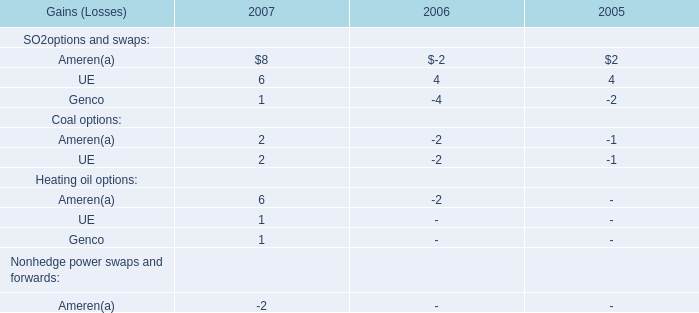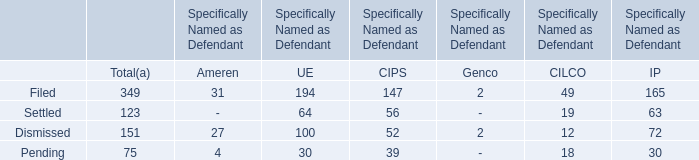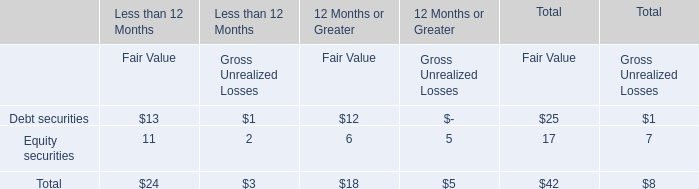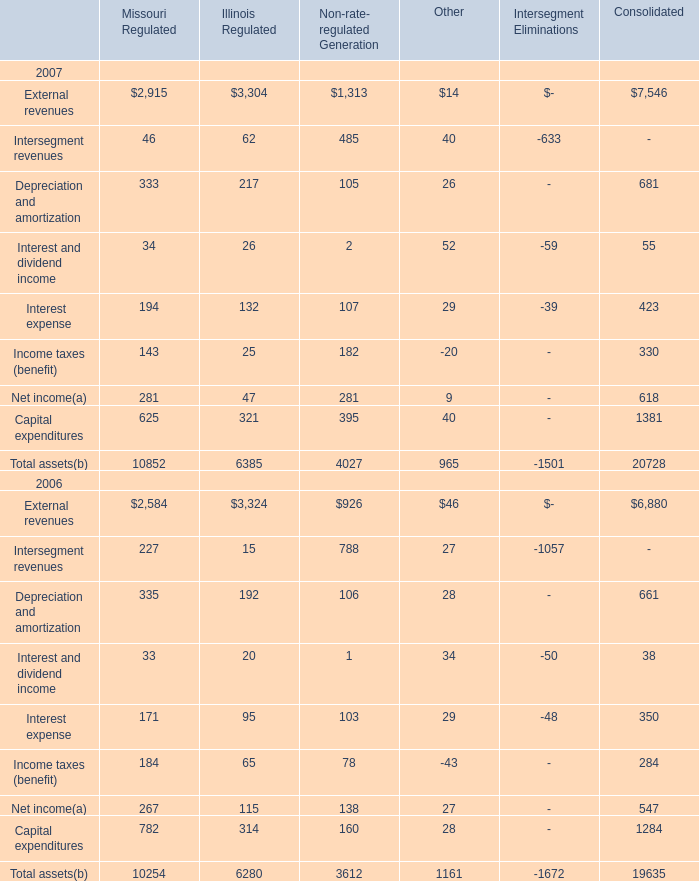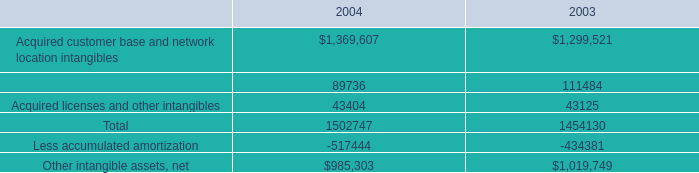If External revenues of Missouri Regulated develops with the same growth rate in 2007, what will it reach in 2008? 
Computations: (2915 + ((2915 * (2915 - 2584)) / 2584))
Answer: 3288.39977. 